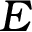<formula> <loc_0><loc_0><loc_500><loc_500>E</formula> 